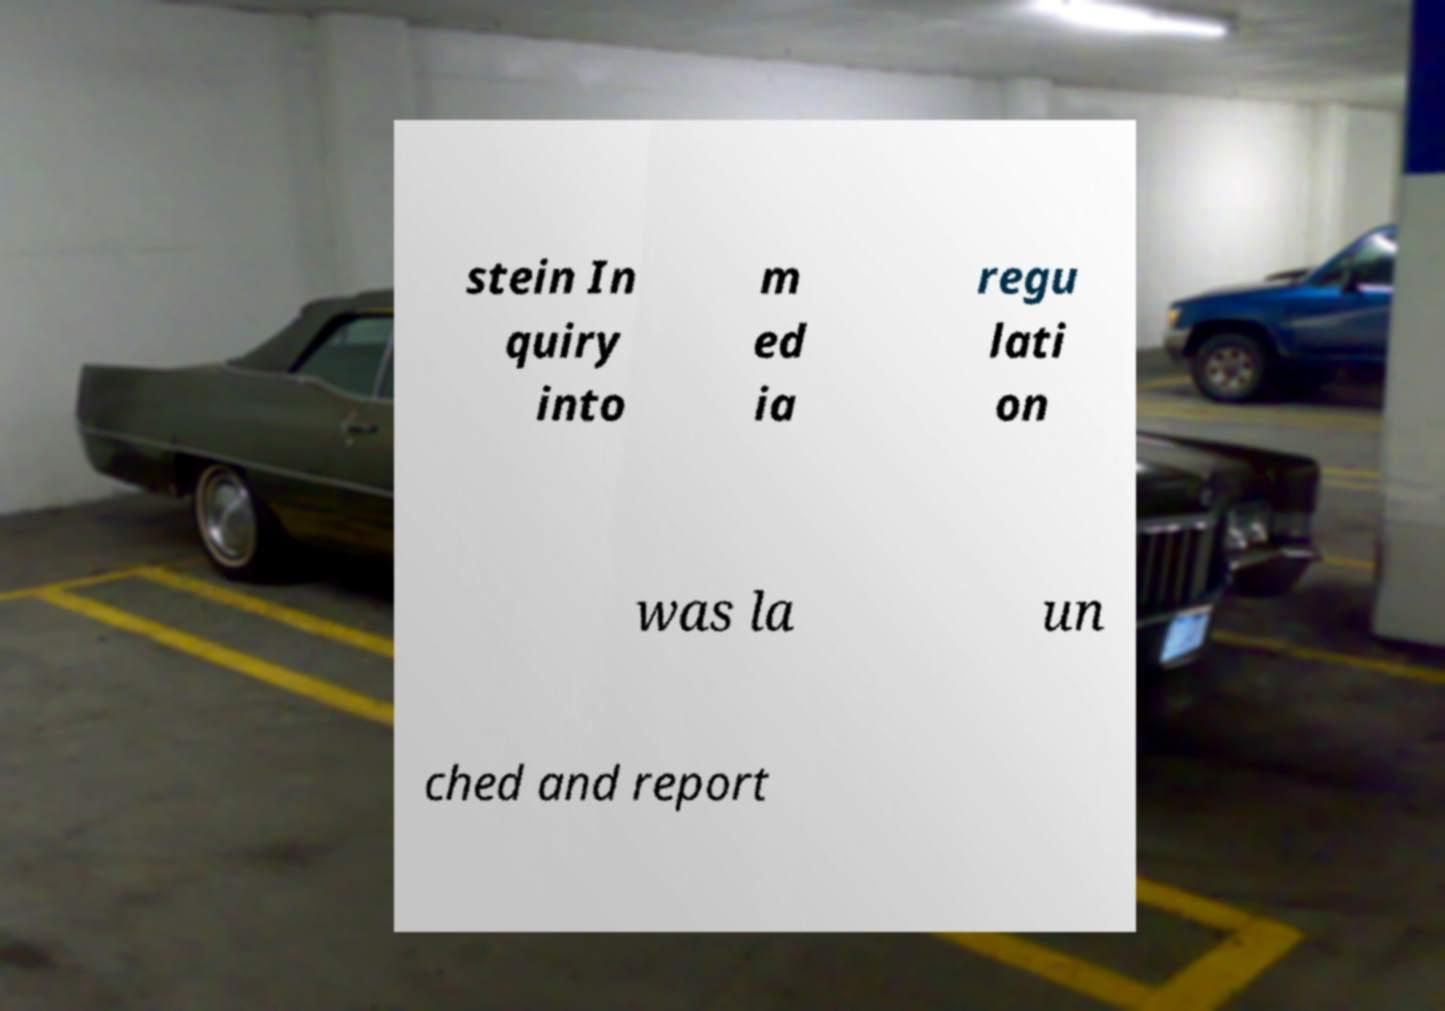Could you extract and type out the text from this image? stein In quiry into m ed ia regu lati on was la un ched and report 